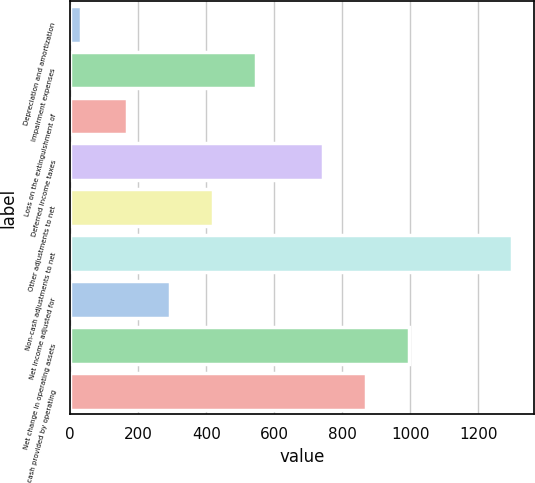<chart> <loc_0><loc_0><loc_500><loc_500><bar_chart><fcel>Depreciation and amortization<fcel>Impairment expenses<fcel>Loss on the extinguishment of<fcel>Deferred income taxes<fcel>Other adjustments to net<fcel>Non-cash adjustments to net<fcel>Net income adjusted for<fcel>Net change in operating assets<fcel>Net cash provided by operating<nl><fcel>32<fcel>546.4<fcel>166<fcel>743<fcel>419.6<fcel>1300<fcel>292.8<fcel>996.6<fcel>869.8<nl></chart> 